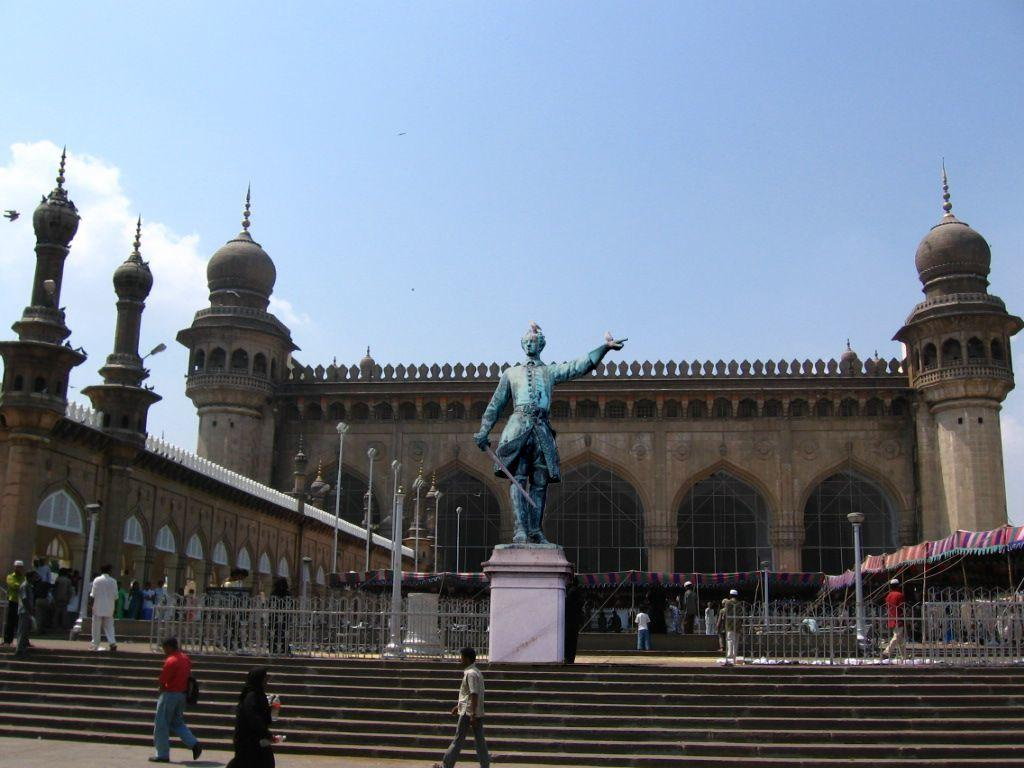What is the color of the sky in the image? The sky is blue in the image. What can be seen in the sky besides the blue color? There are clouds visible in the image. What type of structure is present in the image? There is a building in the image. What is located in front of the building? Light poles, a fence, a tent, a statue, and people are present in front of the building. What architectural feature is located beside the people? Steps are located beside the people. What year is depicted in the image? The image does not depict a specific year; it is a snapshot of the current moment. What activity are the people engaged in within the image? The image does not show the people engaged in any specific activity; they are simply standing in front of the building. 